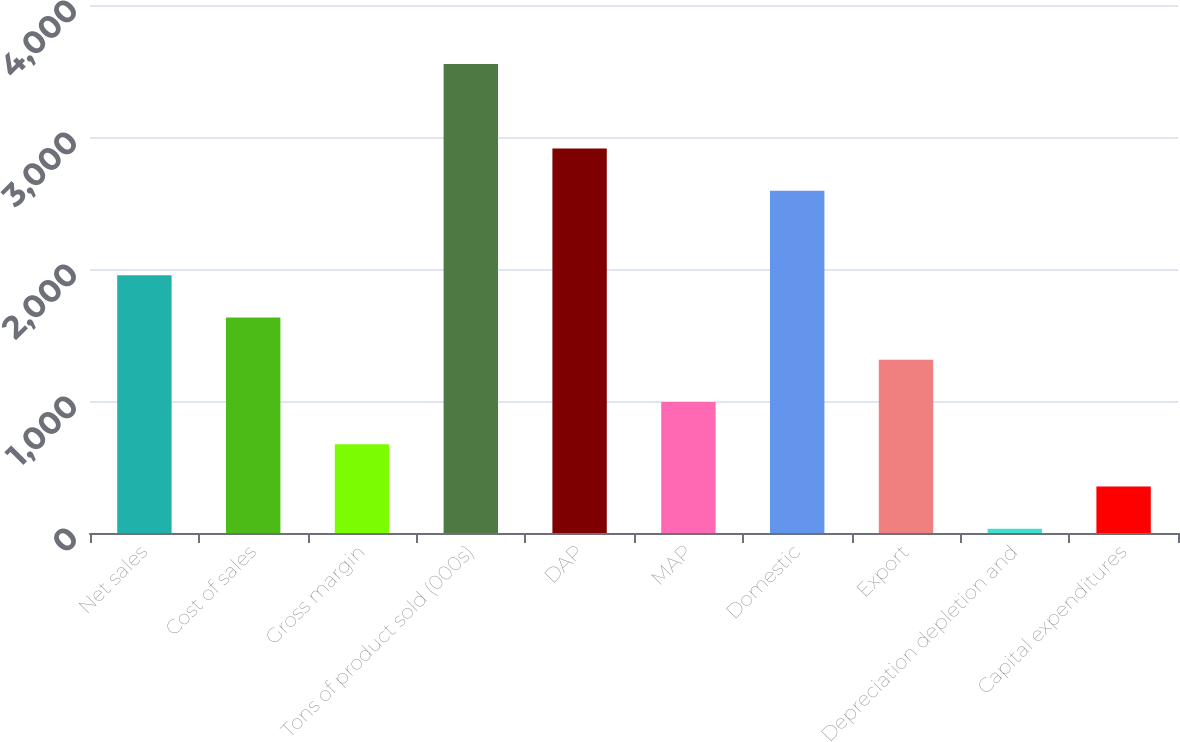Convert chart. <chart><loc_0><loc_0><loc_500><loc_500><bar_chart><fcel>Net sales<fcel>Cost of sales<fcel>Gross margin<fcel>Tons of product sold (000s)<fcel>DAP<fcel>MAP<fcel>Domestic<fcel>Export<fcel>Depreciation depletion and<fcel>Capital expenditures<nl><fcel>1952.4<fcel>1632.25<fcel>671.8<fcel>3553.15<fcel>2912.85<fcel>991.95<fcel>2592.7<fcel>1312.1<fcel>31.5<fcel>351.65<nl></chart> 